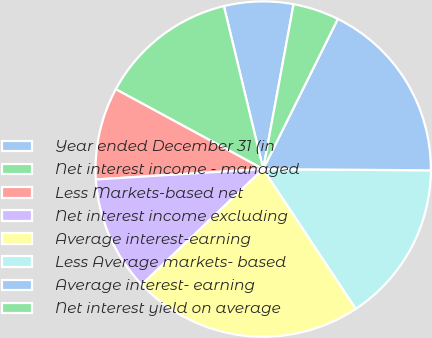<chart> <loc_0><loc_0><loc_500><loc_500><pie_chart><fcel>Year ended December 31 (in<fcel>Net interest income - managed<fcel>Less Markets-based net<fcel>Net interest income excluding<fcel>Average interest-earning<fcel>Less Average markets- based<fcel>Average interest- earning<fcel>Net interest yield on average<nl><fcel>6.67%<fcel>13.33%<fcel>8.89%<fcel>11.11%<fcel>22.22%<fcel>15.56%<fcel>17.78%<fcel>4.44%<nl></chart> 